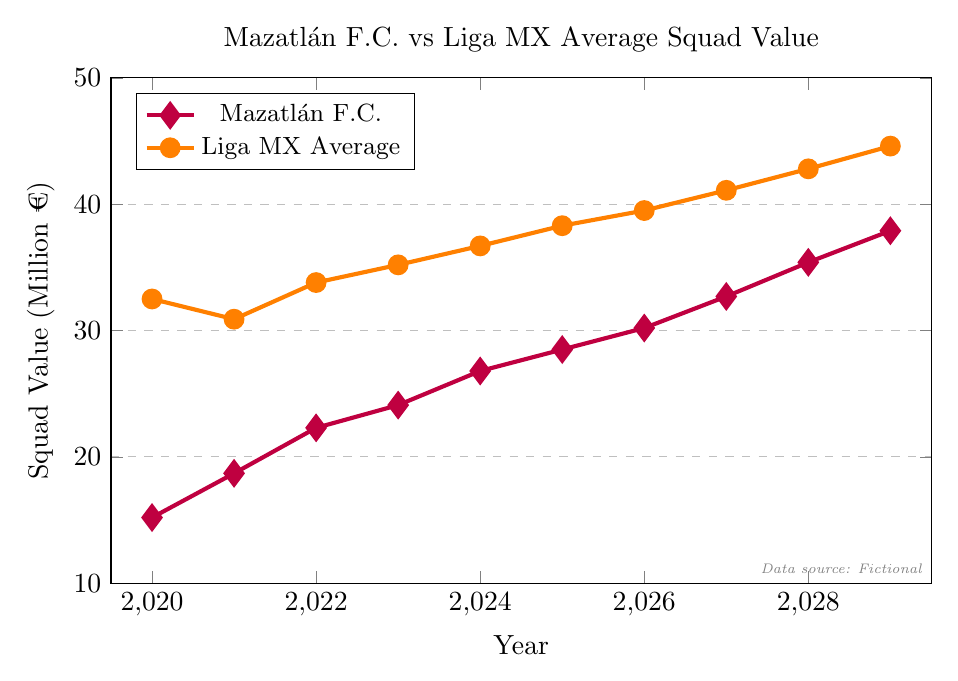Which year does Mazatlán F.C. surpass 30 million € in squad value? From the purple line representing Mazatlán F.C., we see that the squad value surpasses 30 million € in 2026.
Answer: 2026 In which year is the difference between Mazatlán F.C. and the Liga MX average squad value the largest? Calculate the difference between the values for each year and find the maximum difference. The differences are: 17.3 (2020), 12.2 (2021), 11.5 (2022), 11.1 (2023), 9.9 (2024), 9.8 (2025), 9.3 (2026), 8.4 (2027), 7.4 (2028), 6.7 (2029). The largest difference is in 2020.
Answer: 2020 How much does Mazatlán F.C.’s squad value increase from 2020 to 2029? Subtract the 2020 value from the 2029 value: 37.9 million € - 15.2 million € = 22.7 million €.
Answer: 22.7 million € Does Mazatlán F.C.’s squad value ever equal the Liga MX average squad value? From the plot, Mazatlán F.C.’s squad value never intersects with the Liga MX average squad value.
Answer: No What is the compound annual growth rate (CAGR) of Mazatlán F.C.'s squad value from 2020 to 2029? CAGR formula: \((\frac{V_f}{V_i})^{\frac{1}{n}} - 1\), where \(V_f\) is the final value, \(V_i\) is the initial value, and \(n\) is the number of years. For Mazatlán F.C.: \((\frac{37.9}{15.2})^{\frac{1}{9}} - 1\).
Answer: 10.63% Which team has the higher squad value in 2023? Look at the values in 2023: Mazatlán F.C. has 24.1 million €, and Liga MX average is 35.2 million €. The Liga MX average is higher.
Answer: Liga MX average What is the average squad value of Mazatlán F.C. from 2020 to 2029? Sum up all values and divide by the number of years (10): (15.2 + 18.7 + 22.3 + 24.1 + 26.8 + 28.5 + 30.2 + 32.7 + 35.4 + 37.9) / 10 = 27.18 million €.
Answer: 27.18 million € By how much did Mazatlán F.C.’s squad value grow from 2024 to 2025? Subtract the value in 2024 from the value in 2025: 28.5 million € - 26.8 million € = 1.7 million €.
Answer: 1.7 million € Is there a year when Mazatlán F.C's growth rate in squad value exceeds that of Liga MX average? To check growth rates, look at the difference in squad values year-to-year. Comparing each year: 2021 (3.5 vs. -1.6), 2022 (3.6 vs. 2.9), 2023 (1.8 vs. 1.4), 2024 (2.7 vs. 1.5), 2025 (1.7 vs. 1.6), 2026 (1.7 vs. 1.2), 2027 (2.5 vs. 1.6), 2028 (2.7 vs. 1.7), 2029 (2.5 vs. 1.8). In the years 2021, 2022, 2023, 2024, 2026, 2027, 2028, and 2029, Mazatlán F.C.’s growth rate exceeds that of Liga MX.
Answer: Yes 